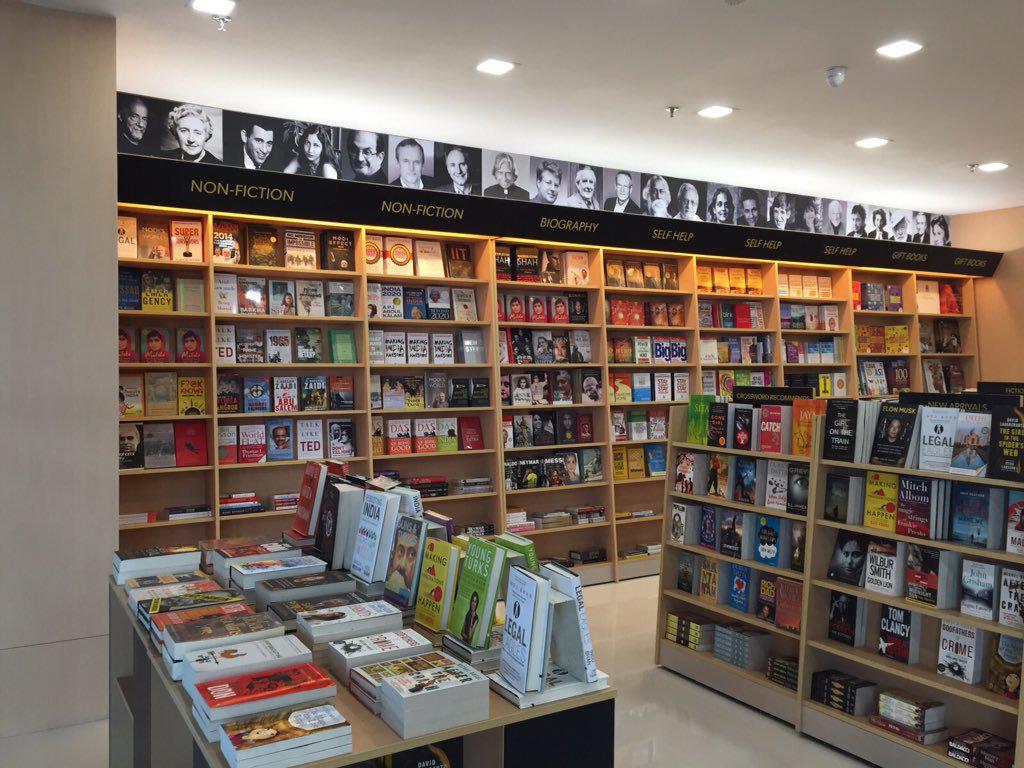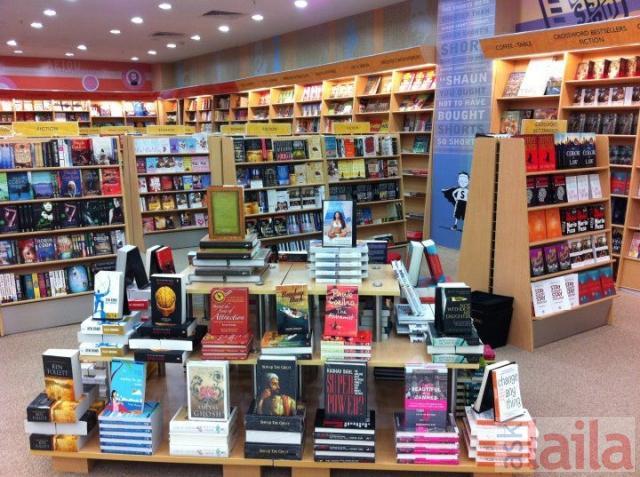The first image is the image on the left, the second image is the image on the right. Examine the images to the left and right. Is the description "The shops are empty." accurate? Answer yes or no. Yes. The first image is the image on the left, the second image is the image on the right. Examine the images to the left and right. Is the description "There is at least one person that is walking in a bookstore near a light brown bookshelf." accurate? Answer yes or no. No. 